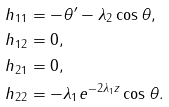<formula> <loc_0><loc_0><loc_500><loc_500>h _ { 1 1 } & = - \theta ^ { \prime } - \lambda _ { 2 } \cos \theta , \\ h _ { 1 2 } & = 0 , \\ h _ { 2 1 } & = 0 , \\ h _ { 2 2 } & = - \lambda _ { 1 } e ^ { - 2 \lambda _ { 1 } z } \cos \theta .</formula> 